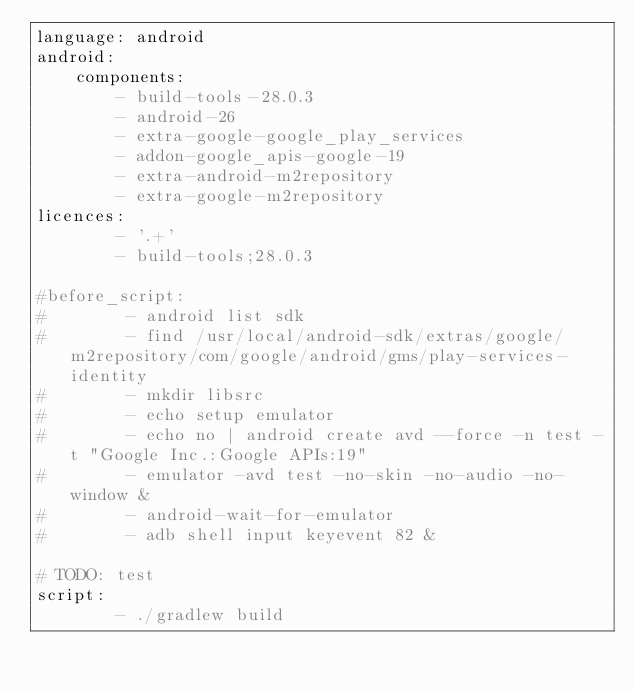<code> <loc_0><loc_0><loc_500><loc_500><_YAML_>language: android
android:
    components:
        - build-tools-28.0.3
        - android-26
        - extra-google-google_play_services
        - addon-google_apis-google-19
        - extra-android-m2repository
        - extra-google-m2repository
licences:
        - '.+'
        - build-tools;28.0.3
       
#before_script:
#        - android list sdk
#        - find /usr/local/android-sdk/extras/google/m2repository/com/google/android/gms/play-services-identity
#        - mkdir libsrc
#        - echo setup emulator
#        - echo no | android create avd --force -n test -t "Google Inc.:Google APIs:19"
#        - emulator -avd test -no-skin -no-audio -no-window &
#        - android-wait-for-emulator
#        - adb shell input keyevent 82 &

# TODO: test
script:
        - ./gradlew build
</code> 